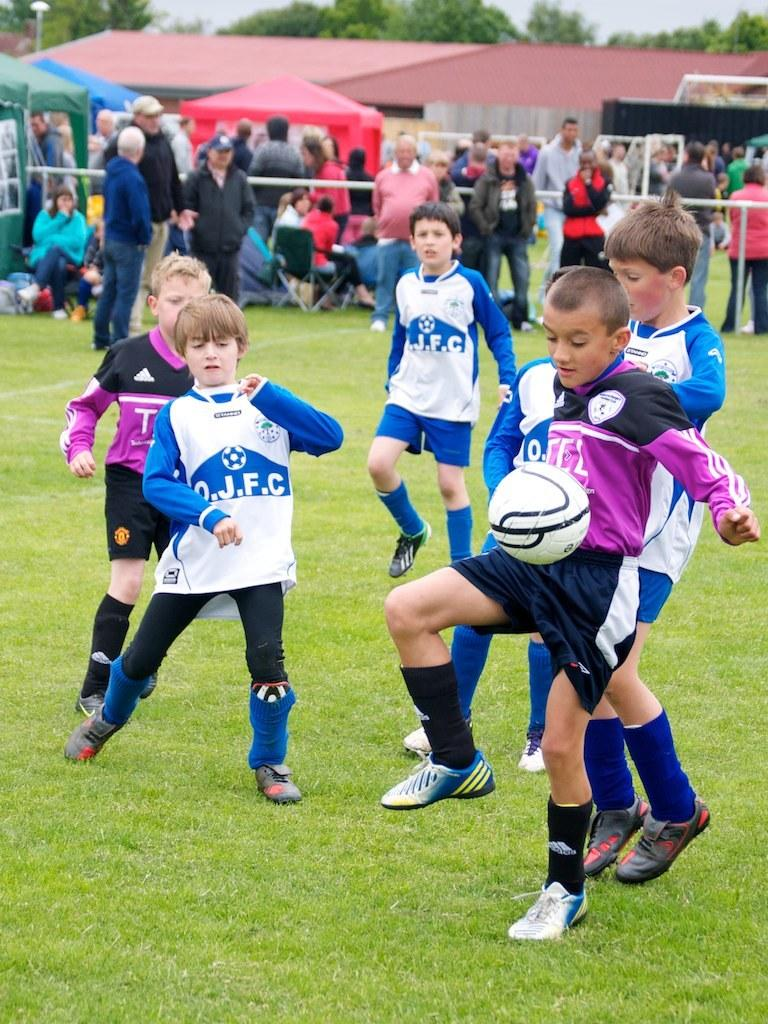What are the people in the image doing? The people in the image are playing a game with a ball. What else can be seen in the image besides the people playing the game? There are tents and a crowd of people in the image. What is visible at the top of the image? Trees are visible at the top of the image. What type of insurance policy is being discussed by the people in the image? There is no indication in the image that the people are discussing any insurance policies. 